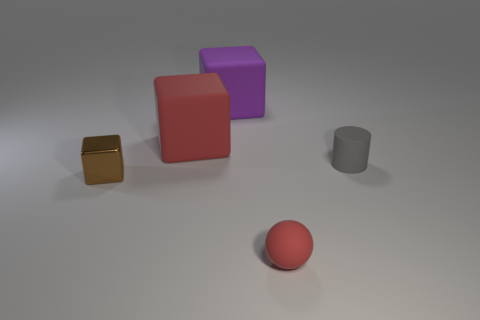The purple thing has what size? The purple object is a cube and, relative to the surrounding objects in the image, it appears to be of medium size. It is larger than the small golden cube and the grey cylinder nearby but smaller than the adjacent red cube. 